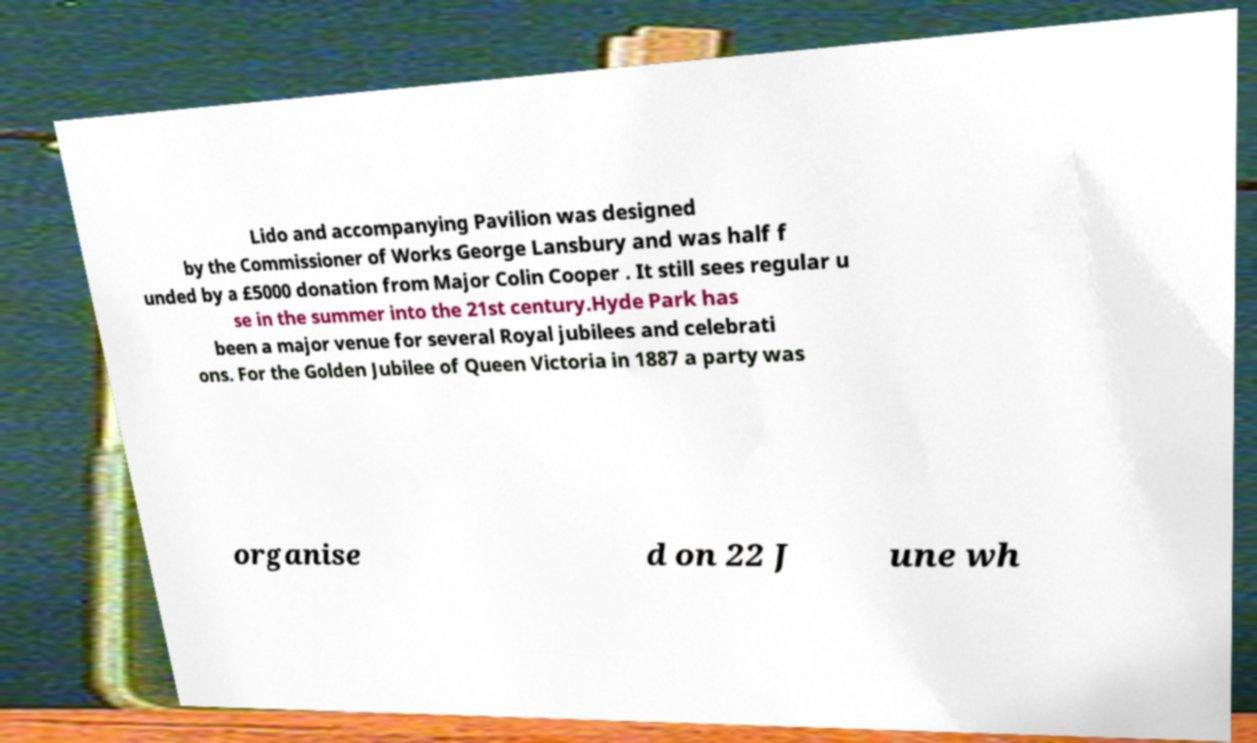Can you read and provide the text displayed in the image?This photo seems to have some interesting text. Can you extract and type it out for me? Lido and accompanying Pavilion was designed by the Commissioner of Works George Lansbury and was half f unded by a £5000 donation from Major Colin Cooper . It still sees regular u se in the summer into the 21st century.Hyde Park has been a major venue for several Royal jubilees and celebrati ons. For the Golden Jubilee of Queen Victoria in 1887 a party was organise d on 22 J une wh 